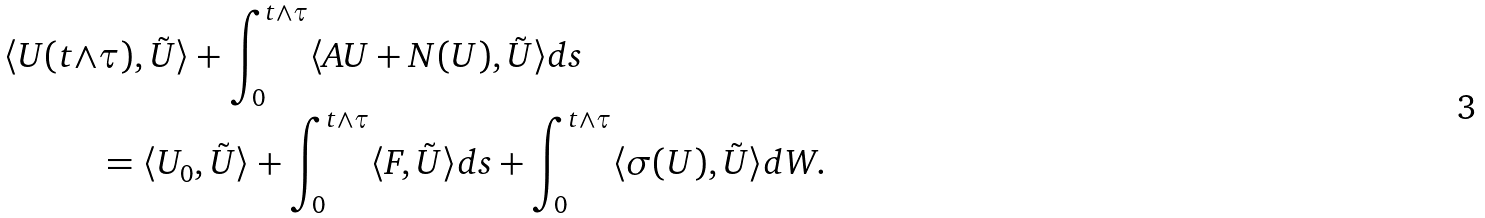Convert formula to latex. <formula><loc_0><loc_0><loc_500><loc_500>\langle U ( t \wedge & \tau ) , \tilde { U } \rangle + \int _ { 0 } ^ { t \wedge \tau } \langle A U + N ( U ) , \tilde { U } \rangle d s \\ & = \langle U _ { 0 } , \tilde { U } \rangle + \int _ { 0 } ^ { t \wedge \tau } \langle F , \tilde { U } \rangle d s + \int _ { 0 } ^ { t \wedge \tau } \langle \sigma ( U ) , \tilde { U } \rangle d W .</formula> 